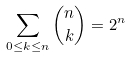Convert formula to latex. <formula><loc_0><loc_0><loc_500><loc_500>\sum _ { 0 \leq { k } \leq { n } } { \binom { n } { k } } = 2 ^ { n }</formula> 